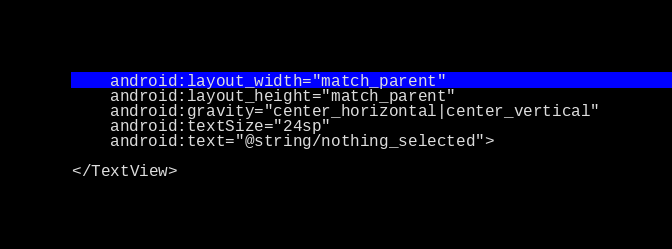<code> <loc_0><loc_0><loc_500><loc_500><_XML_>    android:layout_width="match_parent"
    android:layout_height="match_parent"
    android:gravity="center_horizontal|center_vertical"
    android:textSize="24sp"
    android:text="@string/nothing_selected">

</TextView></code> 